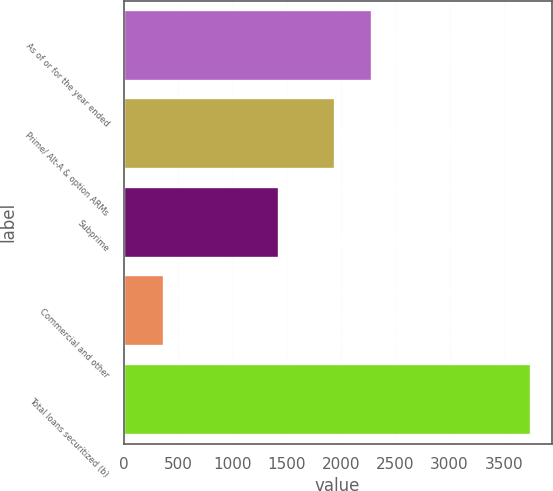<chart> <loc_0><loc_0><loc_500><loc_500><bar_chart><fcel>As of or for the year ended<fcel>Prime/ Alt-A & option ARMs<fcel>Subprime<fcel>Commercial and other<fcel>Total loans securitized (b)<nl><fcel>2283.7<fcel>1946<fcel>1431<fcel>375<fcel>3752<nl></chart> 